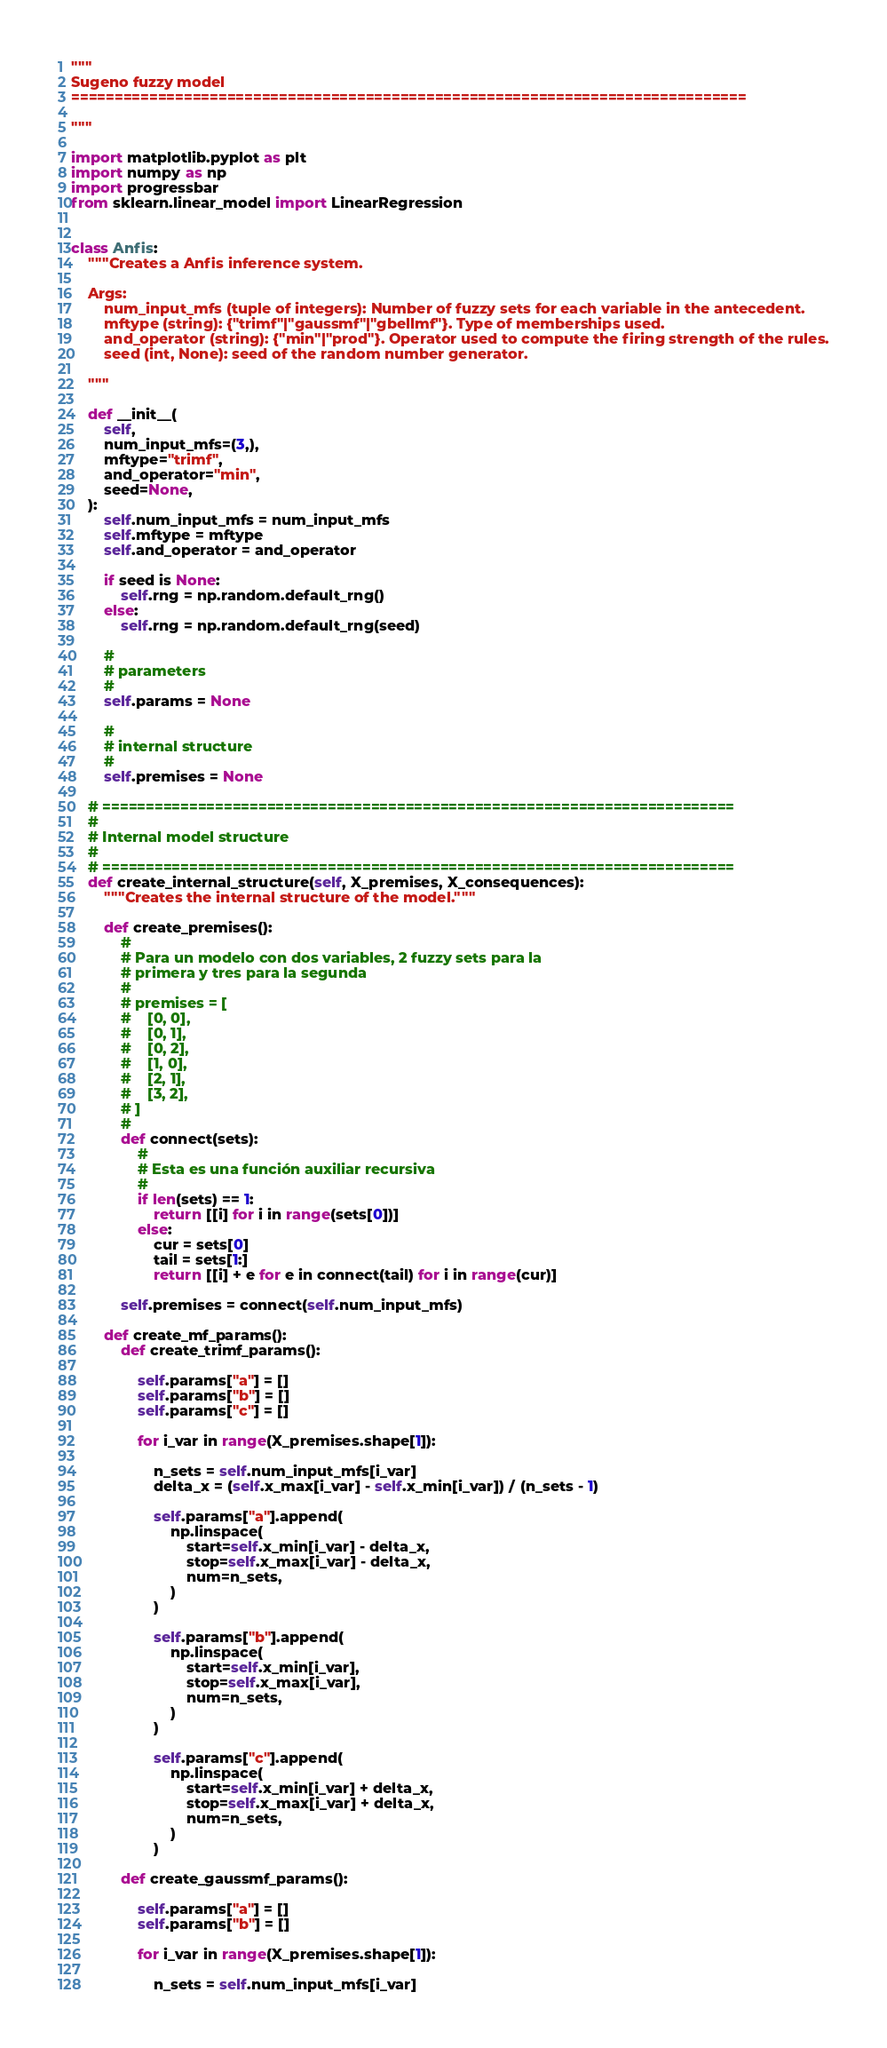<code> <loc_0><loc_0><loc_500><loc_500><_Python_>"""
Sugeno fuzzy model
==============================================================================

"""

import matplotlib.pyplot as plt
import numpy as np
import progressbar
from sklearn.linear_model import LinearRegression


class Anfis:
    """Creates a Anfis inference system.

    Args:
        num_input_mfs (tuple of integers): Number of fuzzy sets for each variable in the antecedent.
        mftype (string): {"trimf"|"gaussmf"|"gbellmf"}. Type of memberships used.
        and_operator (string): {"min"|"prod"}. Operator used to compute the firing strength of the rules.
        seed (int, None): seed of the random number generator.

    """

    def __init__(
        self,
        num_input_mfs=(3,),
        mftype="trimf",
        and_operator="min",
        seed=None,
    ):
        self.num_input_mfs = num_input_mfs
        self.mftype = mftype
        self.and_operator = and_operator

        if seed is None:
            self.rng = np.random.default_rng()
        else:
            self.rng = np.random.default_rng(seed)

        #
        # parameters
        #
        self.params = None

        #
        # internal structure
        #
        self.premises = None

    # =========================================================================
    #
    # Internal model structure
    #
    # =========================================================================
    def create_internal_structure(self, X_premises, X_consequences):
        """Creates the internal structure of the model."""

        def create_premises():
            #
            # Para un modelo con dos variables, 2 fuzzy sets para la
            # primera y tres para la segunda
            #
            # premises = [
            #    [0, 0],
            #    [0, 1],
            #    [0, 2],
            #    [1, 0],
            #    [2, 1],
            #    [3, 2],
            # ]
            #
            def connect(sets):
                #
                # Esta es una función auxiliar recursiva
                #
                if len(sets) == 1:
                    return [[i] for i in range(sets[0])]
                else:
                    cur = sets[0]
                    tail = sets[1:]
                    return [[i] + e for e in connect(tail) for i in range(cur)]

            self.premises = connect(self.num_input_mfs)

        def create_mf_params():
            def create_trimf_params():

                self.params["a"] = []
                self.params["b"] = []
                self.params["c"] = []

                for i_var in range(X_premises.shape[1]):

                    n_sets = self.num_input_mfs[i_var]
                    delta_x = (self.x_max[i_var] - self.x_min[i_var]) / (n_sets - 1)

                    self.params["a"].append(
                        np.linspace(
                            start=self.x_min[i_var] - delta_x,
                            stop=self.x_max[i_var] - delta_x,
                            num=n_sets,
                        )
                    )

                    self.params["b"].append(
                        np.linspace(
                            start=self.x_min[i_var],
                            stop=self.x_max[i_var],
                            num=n_sets,
                        )
                    )

                    self.params["c"].append(
                        np.linspace(
                            start=self.x_min[i_var] + delta_x,
                            stop=self.x_max[i_var] + delta_x,
                            num=n_sets,
                        )
                    )

            def create_gaussmf_params():

                self.params["a"] = []
                self.params["b"] = []

                for i_var in range(X_premises.shape[1]):

                    n_sets = self.num_input_mfs[i_var]</code> 